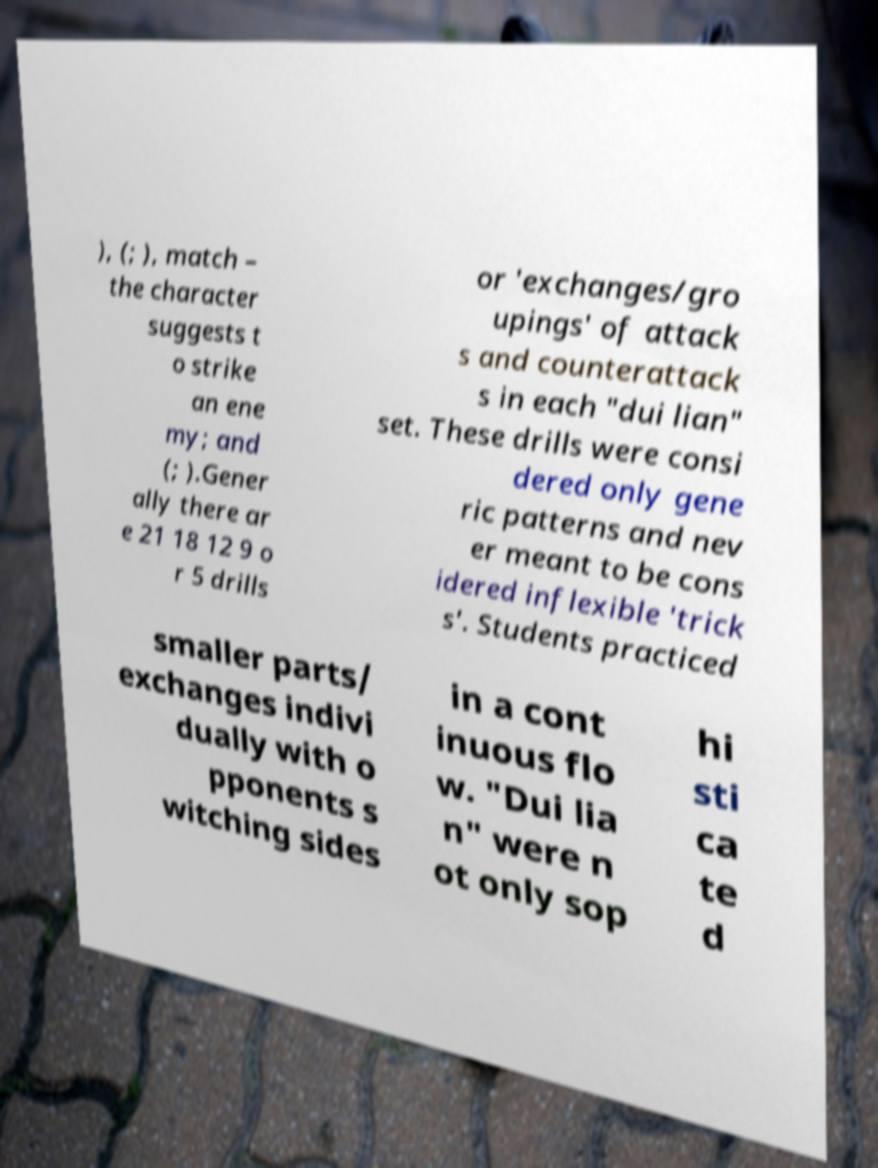I need the written content from this picture converted into text. Can you do that? ), (; ), match – the character suggests t o strike an ene my; and (; ).Gener ally there ar e 21 18 12 9 o r 5 drills or 'exchanges/gro upings' of attack s and counterattack s in each "dui lian" set. These drills were consi dered only gene ric patterns and nev er meant to be cons idered inflexible 'trick s'. Students practiced smaller parts/ exchanges indivi dually with o pponents s witching sides in a cont inuous flo w. "Dui lia n" were n ot only sop hi sti ca te d 